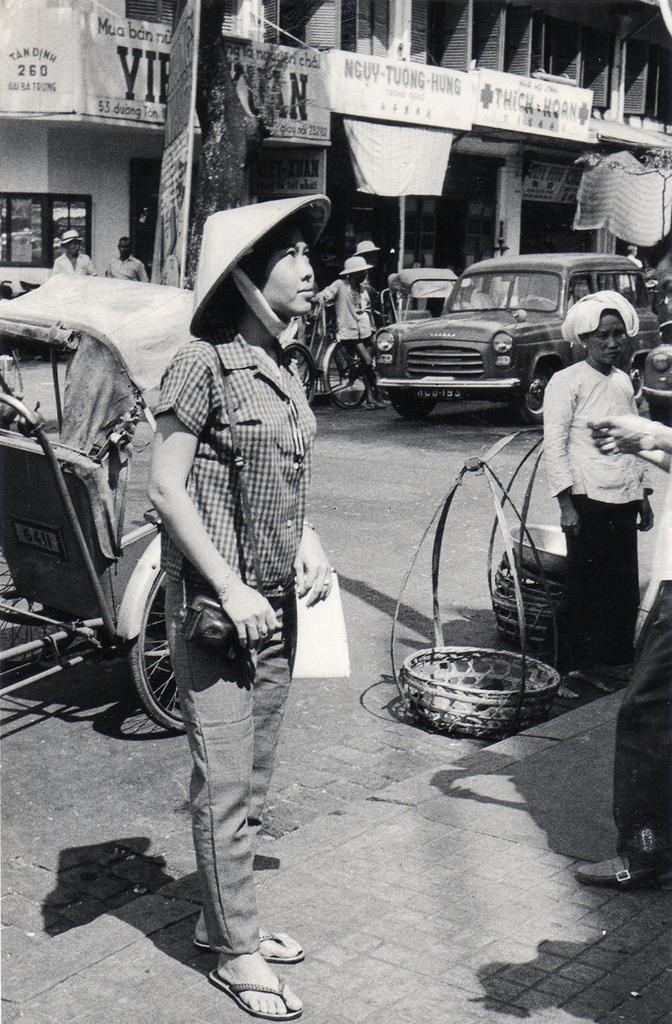Describe this image in one or two sentences. In this image I can see group of people standing, I can also see few vehicles on the road, buildings and few banners attached to the building and the image is in black and white. 